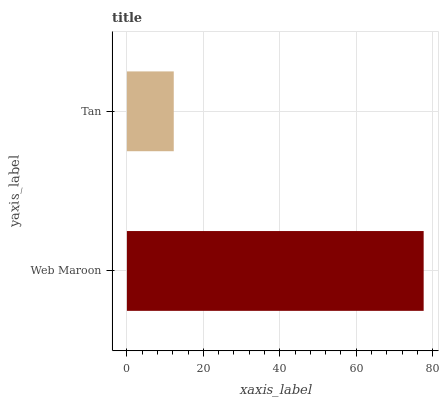Is Tan the minimum?
Answer yes or no. Yes. Is Web Maroon the maximum?
Answer yes or no. Yes. Is Tan the maximum?
Answer yes or no. No. Is Web Maroon greater than Tan?
Answer yes or no. Yes. Is Tan less than Web Maroon?
Answer yes or no. Yes. Is Tan greater than Web Maroon?
Answer yes or no. No. Is Web Maroon less than Tan?
Answer yes or no. No. Is Web Maroon the high median?
Answer yes or no. Yes. Is Tan the low median?
Answer yes or no. Yes. Is Tan the high median?
Answer yes or no. No. Is Web Maroon the low median?
Answer yes or no. No. 